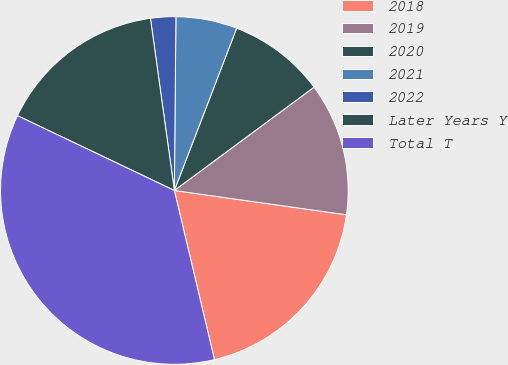<chart> <loc_0><loc_0><loc_500><loc_500><pie_chart><fcel>2018<fcel>2019<fcel>2020<fcel>2021<fcel>2022<fcel>Later Years Y<fcel>Total T<nl><fcel>19.06%<fcel>12.37%<fcel>9.03%<fcel>5.69%<fcel>2.34%<fcel>15.72%<fcel>35.79%<nl></chart> 